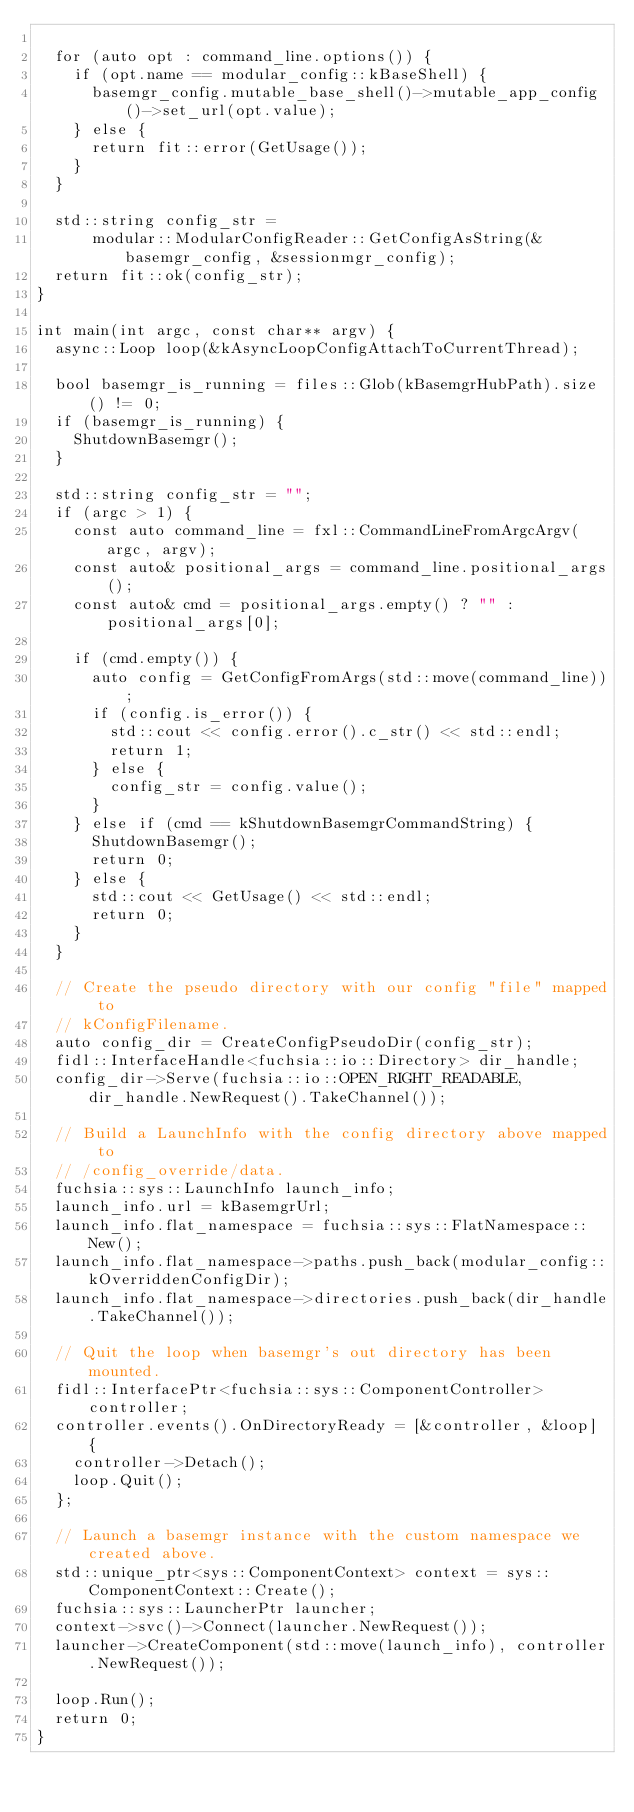<code> <loc_0><loc_0><loc_500><loc_500><_C++_>
  for (auto opt : command_line.options()) {
    if (opt.name == modular_config::kBaseShell) {
      basemgr_config.mutable_base_shell()->mutable_app_config()->set_url(opt.value);
    } else {
      return fit::error(GetUsage());
    }
  }

  std::string config_str =
      modular::ModularConfigReader::GetConfigAsString(&basemgr_config, &sessionmgr_config);
  return fit::ok(config_str);
}

int main(int argc, const char** argv) {
  async::Loop loop(&kAsyncLoopConfigAttachToCurrentThread);

  bool basemgr_is_running = files::Glob(kBasemgrHubPath).size() != 0;
  if (basemgr_is_running) {
    ShutdownBasemgr();
  }

  std::string config_str = "";
  if (argc > 1) {
    const auto command_line = fxl::CommandLineFromArgcArgv(argc, argv);
    const auto& positional_args = command_line.positional_args();
    const auto& cmd = positional_args.empty() ? "" : positional_args[0];

    if (cmd.empty()) {
      auto config = GetConfigFromArgs(std::move(command_line));
      if (config.is_error()) {
        std::cout << config.error().c_str() << std::endl;
        return 1;
      } else {
        config_str = config.value();
      }
    } else if (cmd == kShutdownBasemgrCommandString) {
      ShutdownBasemgr();
      return 0;
    } else {
      std::cout << GetUsage() << std::endl;
      return 0;
    }
  }

  // Create the pseudo directory with our config "file" mapped to
  // kConfigFilename.
  auto config_dir = CreateConfigPseudoDir(config_str);
  fidl::InterfaceHandle<fuchsia::io::Directory> dir_handle;
  config_dir->Serve(fuchsia::io::OPEN_RIGHT_READABLE, dir_handle.NewRequest().TakeChannel());

  // Build a LaunchInfo with the config directory above mapped to
  // /config_override/data.
  fuchsia::sys::LaunchInfo launch_info;
  launch_info.url = kBasemgrUrl;
  launch_info.flat_namespace = fuchsia::sys::FlatNamespace::New();
  launch_info.flat_namespace->paths.push_back(modular_config::kOverriddenConfigDir);
  launch_info.flat_namespace->directories.push_back(dir_handle.TakeChannel());

  // Quit the loop when basemgr's out directory has been mounted.
  fidl::InterfacePtr<fuchsia::sys::ComponentController> controller;
  controller.events().OnDirectoryReady = [&controller, &loop] {
    controller->Detach();
    loop.Quit();
  };

  // Launch a basemgr instance with the custom namespace we created above.
  std::unique_ptr<sys::ComponentContext> context = sys::ComponentContext::Create();
  fuchsia::sys::LauncherPtr launcher;
  context->svc()->Connect(launcher.NewRequest());
  launcher->CreateComponent(std::move(launch_info), controller.NewRequest());

  loop.Run();
  return 0;
}
</code> 